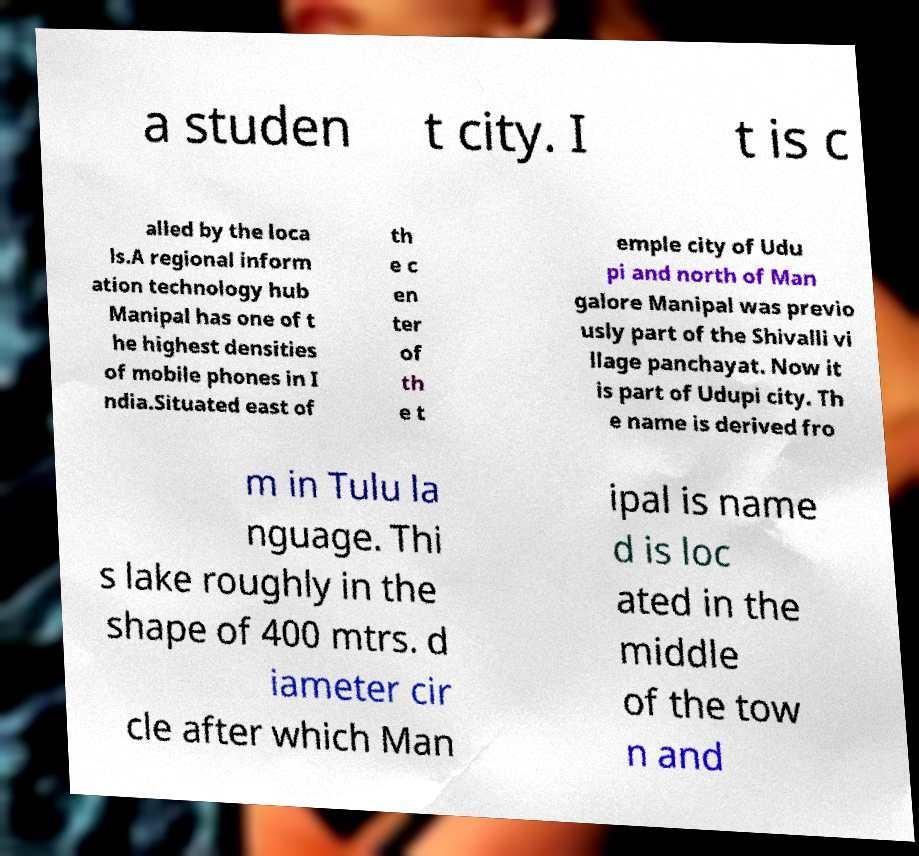There's text embedded in this image that I need extracted. Can you transcribe it verbatim? a studen t city. I t is c alled by the loca ls.A regional inform ation technology hub Manipal has one of t he highest densities of mobile phones in I ndia.Situated east of th e c en ter of th e t emple city of Udu pi and north of Man galore Manipal was previo usly part of the Shivalli vi llage panchayat. Now it is part of Udupi city. Th e name is derived fro m in Tulu la nguage. Thi s lake roughly in the shape of 400 mtrs. d iameter cir cle after which Man ipal is name d is loc ated in the middle of the tow n and 